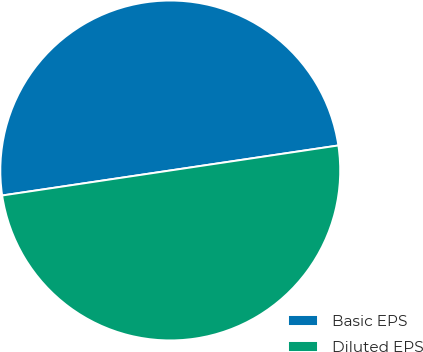<chart> <loc_0><loc_0><loc_500><loc_500><pie_chart><fcel>Basic EPS<fcel>Diluted EPS<nl><fcel>50.0%<fcel>50.0%<nl></chart> 